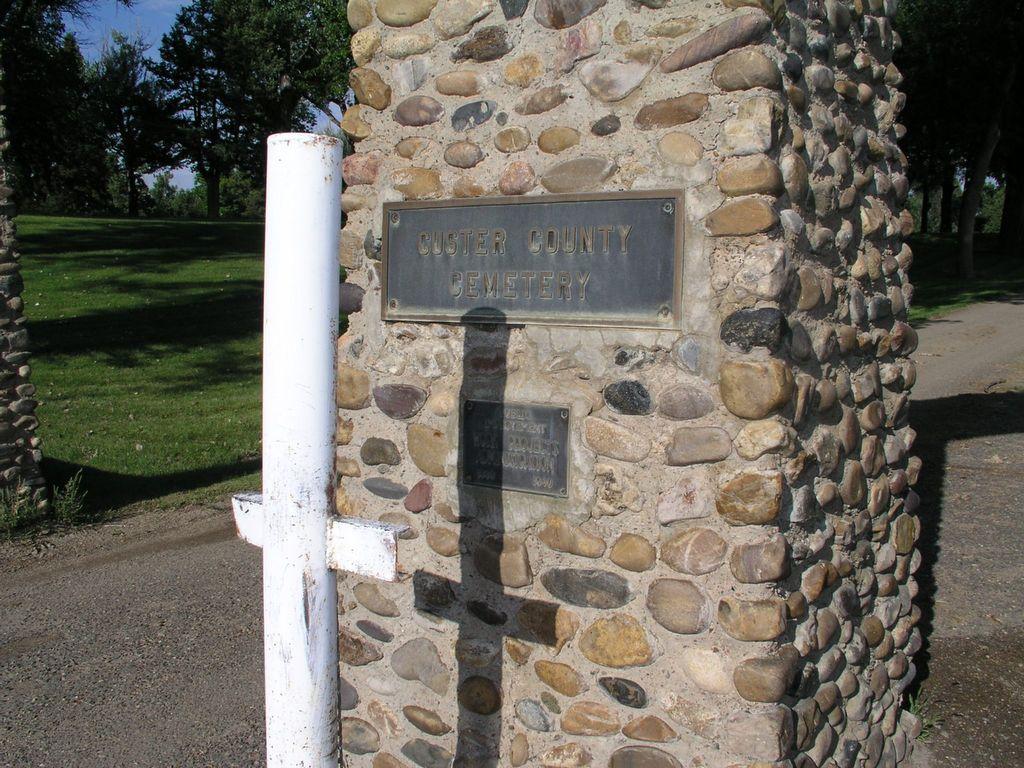In one or two sentences, can you explain what this image depicts? In this picture I can see the board on the wall. beside that I can see the white pole. On the right I can see the road. In the background I can see many trees, plants and grass. In the top left corner I can see the sky. 